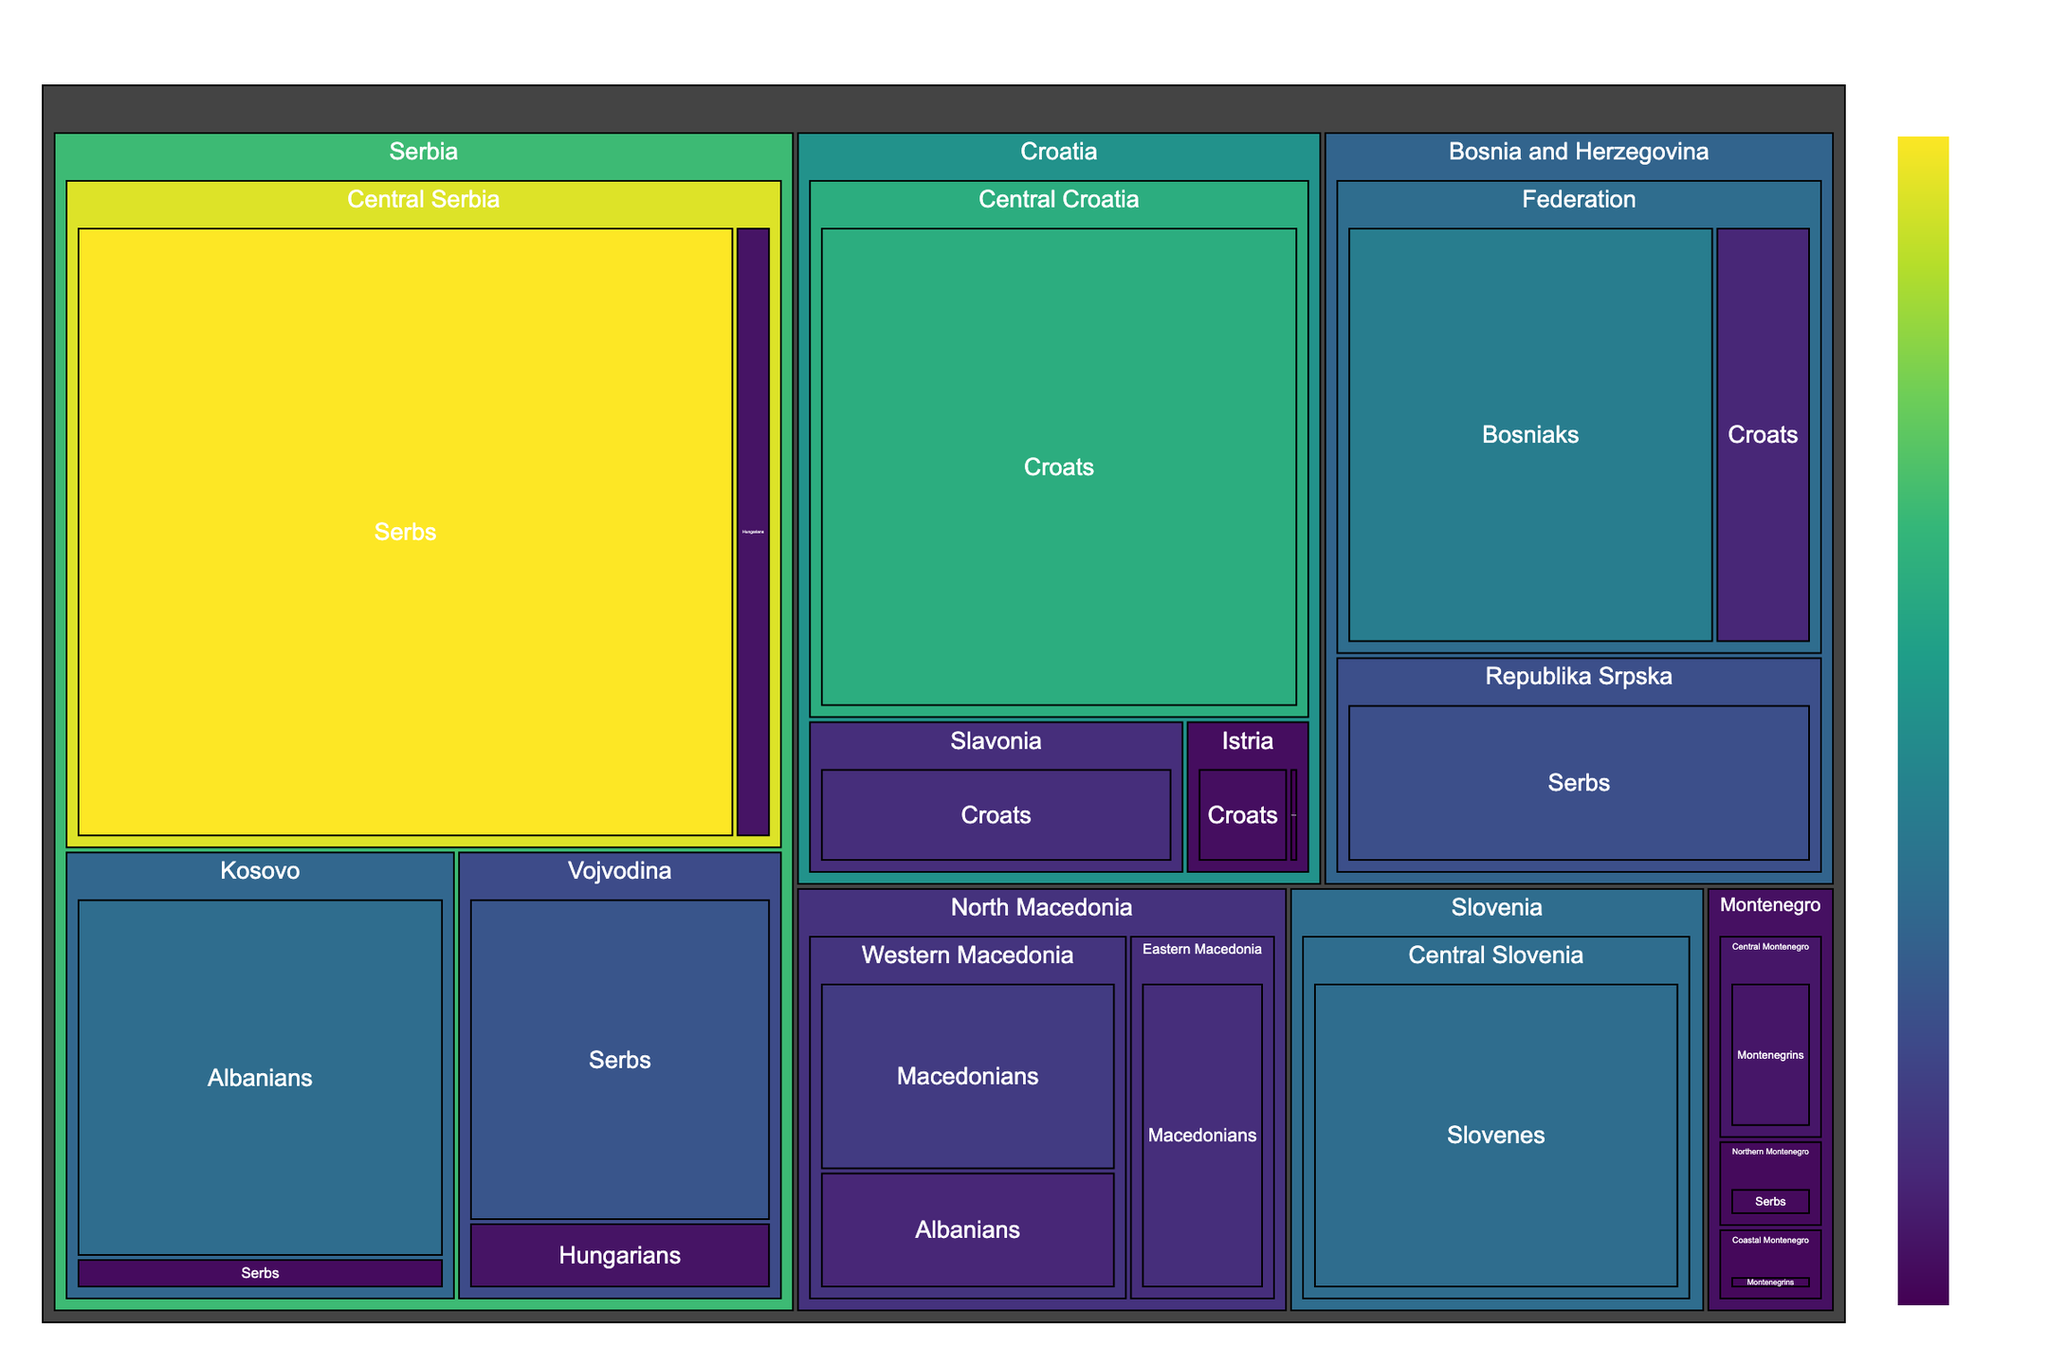What is the total population of Serbs in Serbia? First, locate all the sections related to Serbs within Serbia, which are in Central Serbia and Vojvodina. Sum their populations: 4,500,000 (Central Serbia) + 1,200,000 (Vojvodina) = 5,700,000.
Answer: 5,700,000 Which country has the highest population of Albanians? Identify all regions that list Albanians. In the figure, Kosovo in Serbia and Western Macedonia in North Macedonia have Albanian populations. Compare the populations: 1,600,000 (Kosovo) vs. 500,000 (Western Macedonia). Kosovo has a higher population of Albanians.
Answer: Serbia What is the ethnic group with the smallest population in Slovenia? Look at the sections specific to Slovenia. There are two ethnic groups: Slovenes in Central Slovenia with 1,600,000 and Hungarians in Eastern Slovenia with 8,000. Hungarians have the smaller population.
Answer: Hungarians How many ethnic groups are represented in Bosnia and Herzegovina? Examine Bosnia and Herzegovina and count the unique ethnic groups represented. The figure shows: Bosniaks, Croats, and Serbs.
Answer: 3 What's the total population of ethnic groups in Montenegro? Identify the population of each ethnic group within Montenegro. Sum them up: Montenegrins (Central) 280,000 + Serbs (Northern) 120,000 + Montenegrins (Coastal) 100,000 = 500,000.
Answer: 500,000 Which region in Croatia has the highest population? Identify all regions within Croatia and their populations from the figure: Central Croatia (2,800,000), Slavonia (600,000), and Istria (180,000 + 20,000 = 200,000). Central Croatia has the highest population.
Answer: Central Croatia Compare the population of Macedonians in Western Macedonia and Eastern Macedonia. Which is greater? Identify the population of Macedonians in Western Macedonia (800,000) and Eastern Macedonia (600,000). Western Macedonia has a greater population of Macedonians.
Answer: Western Macedonia What's the dominant ethnic group in Republika Srpska, Bosnia and Herzegovina? Look at the data for Republika Srpska in the figure and identify the ethnic group with the highest population: Serbs with 1,100,000.
Answer: Serbs What is the total population of Hungarians in Serbia? Identify and sum the Hungarian populations in Serbia from the figure: Central Serbia (250,000) + Vojvodina (250,000) = 500,000.
Answer: 500,000 What is the relative size of the Italian population compared to the Croat population in Istria, Croatia? Identify the population of Italians (20,000) and Croats (180,000) in Istria and calculate the ratio: 20,000 / 180,000 = 0.111, meaning Italians make up about 11.1% of the Croat population in Istria.
Answer: 11.1% 